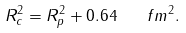<formula> <loc_0><loc_0><loc_500><loc_500>R ^ { 2 } _ { c } = R ^ { 2 } _ { p } + 0 . 6 4 \quad f m ^ { 2 } .</formula> 